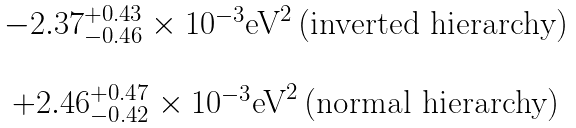<formula> <loc_0><loc_0><loc_500><loc_500>\begin{matrix} - 2 . 3 7 _ { - 0 . 4 6 } ^ { + 0 . 4 3 } \times 1 0 ^ { - 3 } \text {eV} ^ { 2 } \, \text {(inverted hierarchy)} \\ \\ + 2 . 4 6 _ { - 0 . 4 2 } ^ { + 0 . 4 7 } \times 1 0 ^ { - 3 } \text {eV} ^ { 2 } \, \text {(normal hierarchy)} \end{matrix}</formula> 